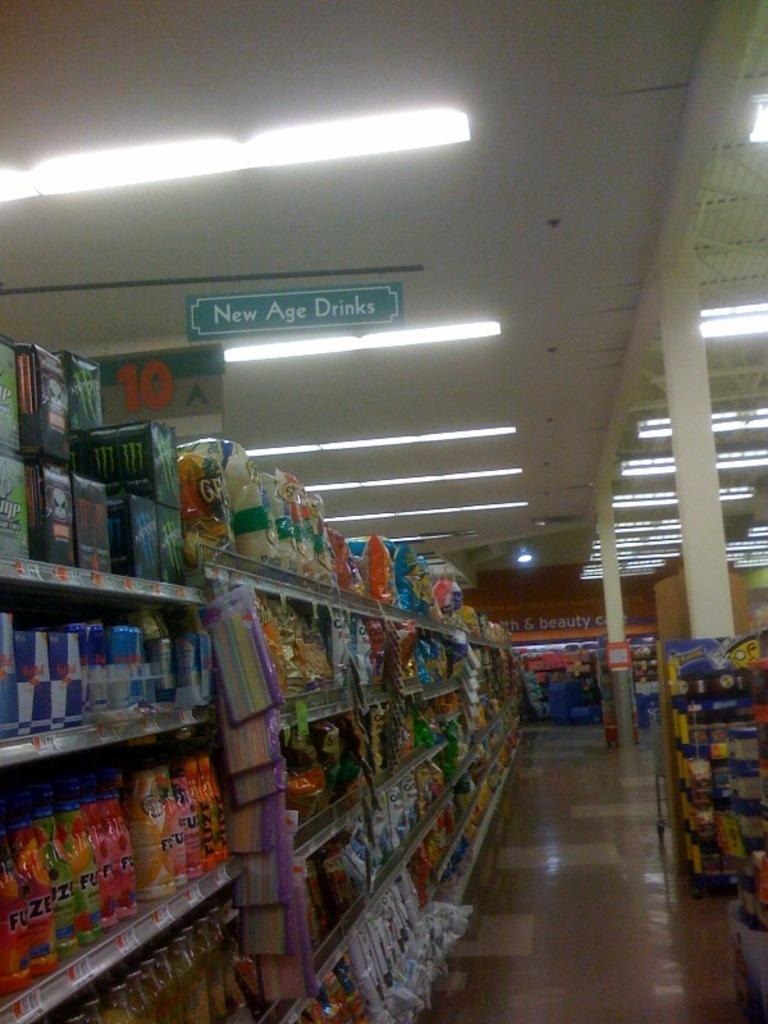Provide a one-sentence caption for the provided image. A grocery store aisle features New Age Drinks. 